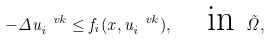Convert formula to latex. <formula><loc_0><loc_0><loc_500><loc_500>- \Delta u _ { i } ^ { \ v k } \leq f _ { i } ( x , u _ { i } ^ { \ v k } ) , \quad \text {in } \tilde { \Omega } ,</formula> 